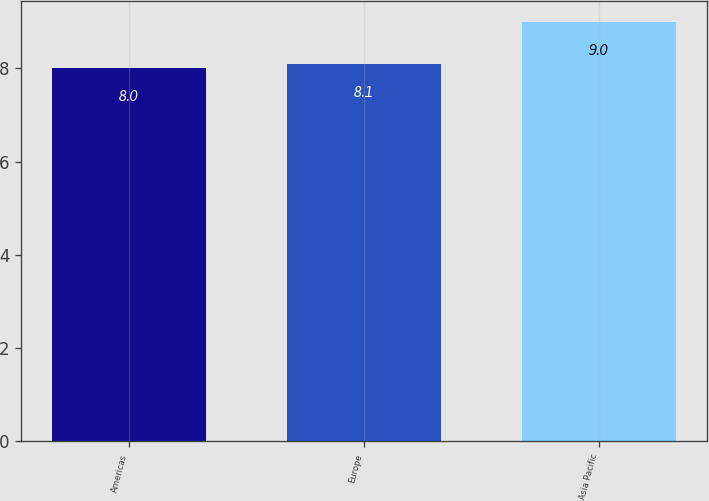Convert chart to OTSL. <chart><loc_0><loc_0><loc_500><loc_500><bar_chart><fcel>Americas<fcel>Europe<fcel>Asia Pacific<nl><fcel>8<fcel>8.1<fcel>9<nl></chart> 